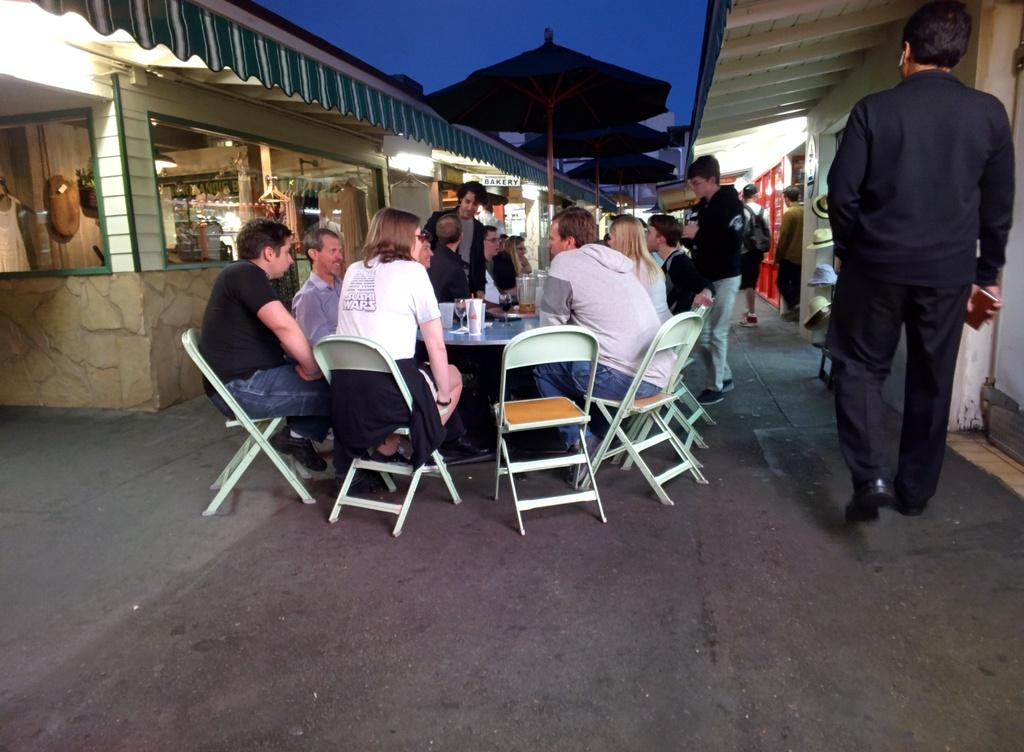What are the people near the table doing in the image? The people sitting on chairs near a table are likely having a meal or conversation. What can be seen in the distance behind the people? Stores and umbrellas are visible in the background. What is the activity of the people in the background? People are walking in the background. Where is the mailbox located in the image? There is no mailbox present in the image. What type of skate is being used by the people walking in the background? There is no skate visible in the image; people are walking on foot. 